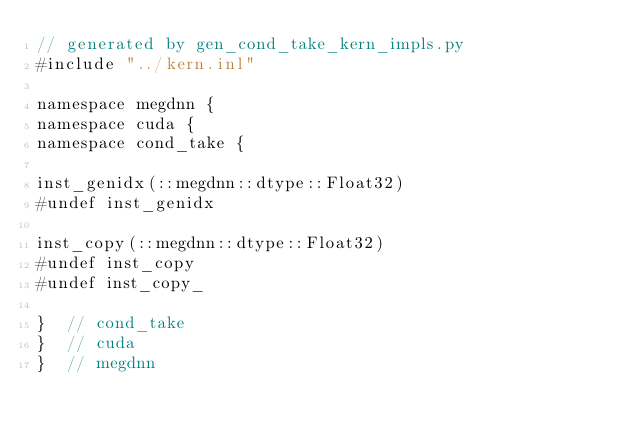Convert code to text. <code><loc_0><loc_0><loc_500><loc_500><_Cuda_>// generated by gen_cond_take_kern_impls.py
#include "../kern.inl"

namespace megdnn {
namespace cuda {
namespace cond_take {

inst_genidx(::megdnn::dtype::Float32)
#undef inst_genidx

inst_copy(::megdnn::dtype::Float32)
#undef inst_copy
#undef inst_copy_

}  // cond_take
}  // cuda
}  // megdnn
</code> 